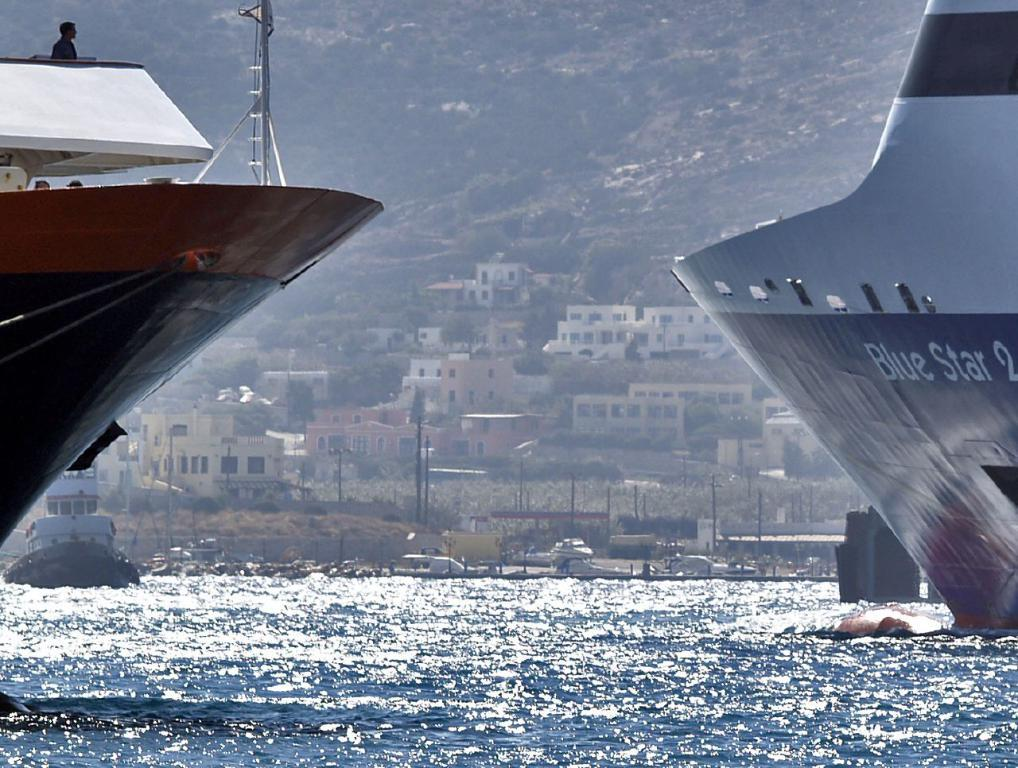<image>
Present a compact description of the photo's key features. A blue & white ship on right, containing the words Blue Star, and a black, red & white ship on left and a town in background. 